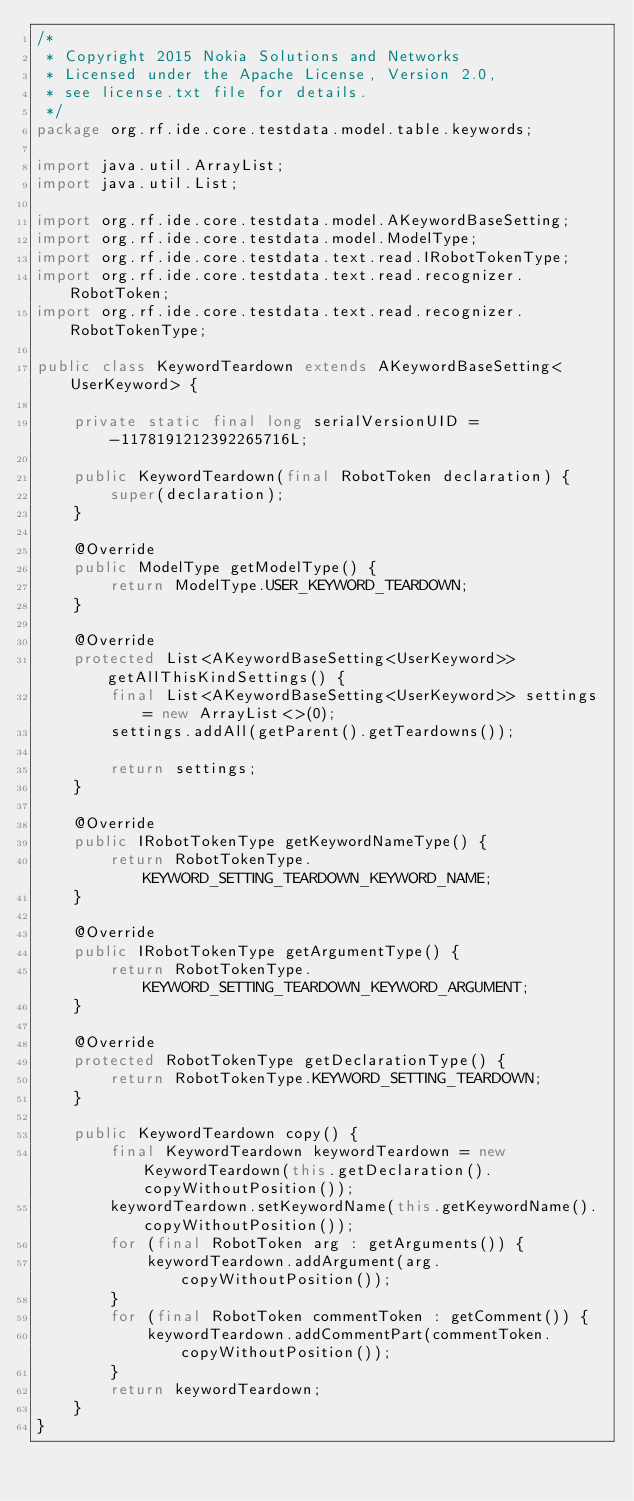Convert code to text. <code><loc_0><loc_0><loc_500><loc_500><_Java_>/*
 * Copyright 2015 Nokia Solutions and Networks
 * Licensed under the Apache License, Version 2.0,
 * see license.txt file for details.
 */
package org.rf.ide.core.testdata.model.table.keywords;

import java.util.ArrayList;
import java.util.List;

import org.rf.ide.core.testdata.model.AKeywordBaseSetting;
import org.rf.ide.core.testdata.model.ModelType;
import org.rf.ide.core.testdata.text.read.IRobotTokenType;
import org.rf.ide.core.testdata.text.read.recognizer.RobotToken;
import org.rf.ide.core.testdata.text.read.recognizer.RobotTokenType;

public class KeywordTeardown extends AKeywordBaseSetting<UserKeyword> {

    private static final long serialVersionUID = -1178191212392265716L;

    public KeywordTeardown(final RobotToken declaration) {
        super(declaration);
    }

    @Override
    public ModelType getModelType() {
        return ModelType.USER_KEYWORD_TEARDOWN;
    }

    @Override
    protected List<AKeywordBaseSetting<UserKeyword>> getAllThisKindSettings() {
        final List<AKeywordBaseSetting<UserKeyword>> settings = new ArrayList<>(0);
        settings.addAll(getParent().getTeardowns());

        return settings;
    }

    @Override
    public IRobotTokenType getKeywordNameType() {
        return RobotTokenType.KEYWORD_SETTING_TEARDOWN_KEYWORD_NAME;
    }

    @Override
    public IRobotTokenType getArgumentType() {
        return RobotTokenType.KEYWORD_SETTING_TEARDOWN_KEYWORD_ARGUMENT;
    }

    @Override
    protected RobotTokenType getDeclarationType() {
        return RobotTokenType.KEYWORD_SETTING_TEARDOWN;
    }
    
    public KeywordTeardown copy() {
        final KeywordTeardown keywordTeardown = new KeywordTeardown(this.getDeclaration().copyWithoutPosition());
        keywordTeardown.setKeywordName(this.getKeywordName().copyWithoutPosition());
        for (final RobotToken arg : getArguments()) {
            keywordTeardown.addArgument(arg.copyWithoutPosition());
        }
        for (final RobotToken commentToken : getComment()) {
            keywordTeardown.addCommentPart(commentToken.copyWithoutPosition());
        }
        return keywordTeardown;
    }
}
</code> 